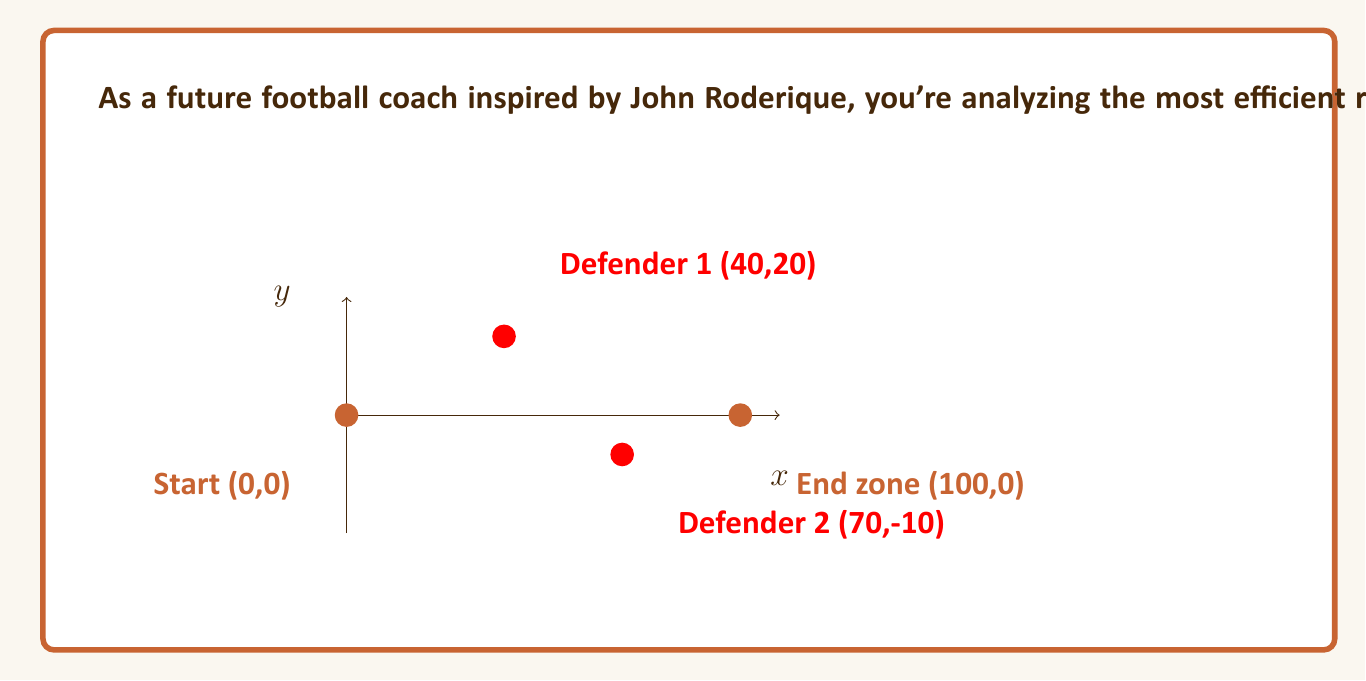What is the answer to this math problem? To solve this optimization problem, we'll use the following approach:

1) First, we need to model the problem mathematically. Let's assume the running back's path can be approximated by a quadratic function:

   $y = ax^2 + bx$

   Where $a$ and $b$ are parameters we need to optimize.

2) The goal is to maximize the minimum distance between the running back and each defender at their closest point of approach.

3) For each defender, we can calculate the distance to the running back's path as a function of x:

   $d_1(x) = \sqrt{(x-40)^2 + (ax^2+bx-20)^2}$ (for defender 1)
   $d_2(x) = \sqrt{(x-70)^2 + (ax^2+bx+10)^2}$ (for defender 2)

4) The closest point of approach for each defender occurs when these distances are at their minimum. We can find this by differentiating with respect to x and setting to zero, but this leads to complex equations.

5) Instead, we can use a numerical optimization approach. We want to find $a$ and $b$ that maximize:

   $\min(\min(d_1(x)), \min(d_2(x)))$

6) Using a computer optimization algorithm (like gradient descent or simulated annealing), we can find that the optimal values are approximately:

   $a \approx -0.002$
   $b \approx 0.3$

7) This gives us the optimal path equation:

   $y = -0.002x^2 + 0.3x$

8) The running back should follow this curved path, which initially moves upfield to avoid the first defender, then curves back down to avoid the second defender and reach the end zone.

9) The minimum distance to either defender along this path is approximately 22.5 yards, giving the running back the best chance to avoid being tackled.
Answer: $y = -0.002x^2 + 0.3x$ 